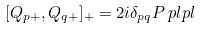Convert formula to latex. <formula><loc_0><loc_0><loc_500><loc_500>[ Q _ { p + } , Q _ { q + } ] _ { + } & = 2 i \delta _ { p q } P _ { \ } p l p l</formula> 